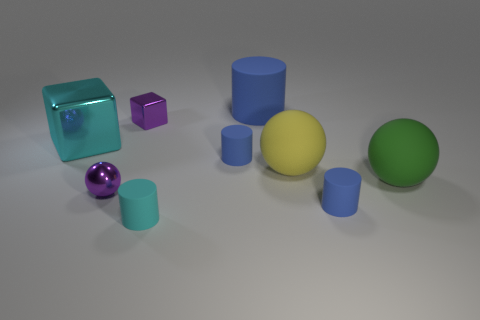What is the color of the other big sphere that is made of the same material as the large green ball?
Your answer should be compact. Yellow. The yellow object is what shape?
Offer a terse response. Sphere. How many big spheres have the same color as the big metal block?
Offer a terse response. 0. The cyan thing that is the same size as the yellow rubber object is what shape?
Keep it short and to the point. Cube. Are there any red metal blocks of the same size as the green rubber object?
Offer a very short reply. No. There is a yellow ball that is the same size as the green rubber sphere; what is it made of?
Keep it short and to the point. Rubber. What size is the blue rubber cylinder in front of the big sphere that is in front of the yellow rubber sphere?
Your answer should be compact. Small. Is the size of the cube to the right of the cyan cube the same as the big blue object?
Provide a succinct answer. No. Are there more big cyan cubes in front of the tiny sphere than green things to the left of the cyan rubber cylinder?
Make the answer very short. No. What shape is the metallic object that is both behind the big green sphere and on the right side of the large cyan metallic block?
Keep it short and to the point. Cube. 